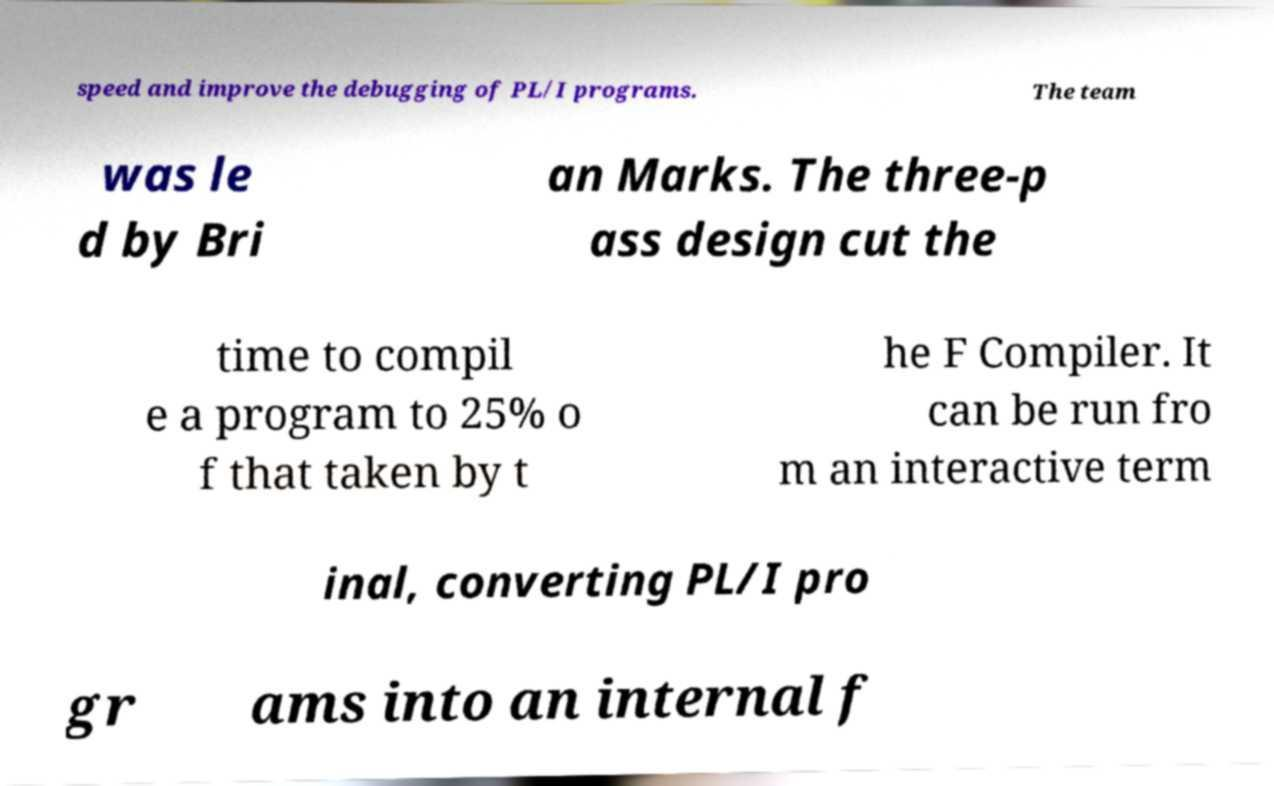Please read and relay the text visible in this image. What does it say? speed and improve the debugging of PL/I programs. The team was le d by Bri an Marks. The three-p ass design cut the time to compil e a program to 25% o f that taken by t he F Compiler. It can be run fro m an interactive term inal, converting PL/I pro gr ams into an internal f 